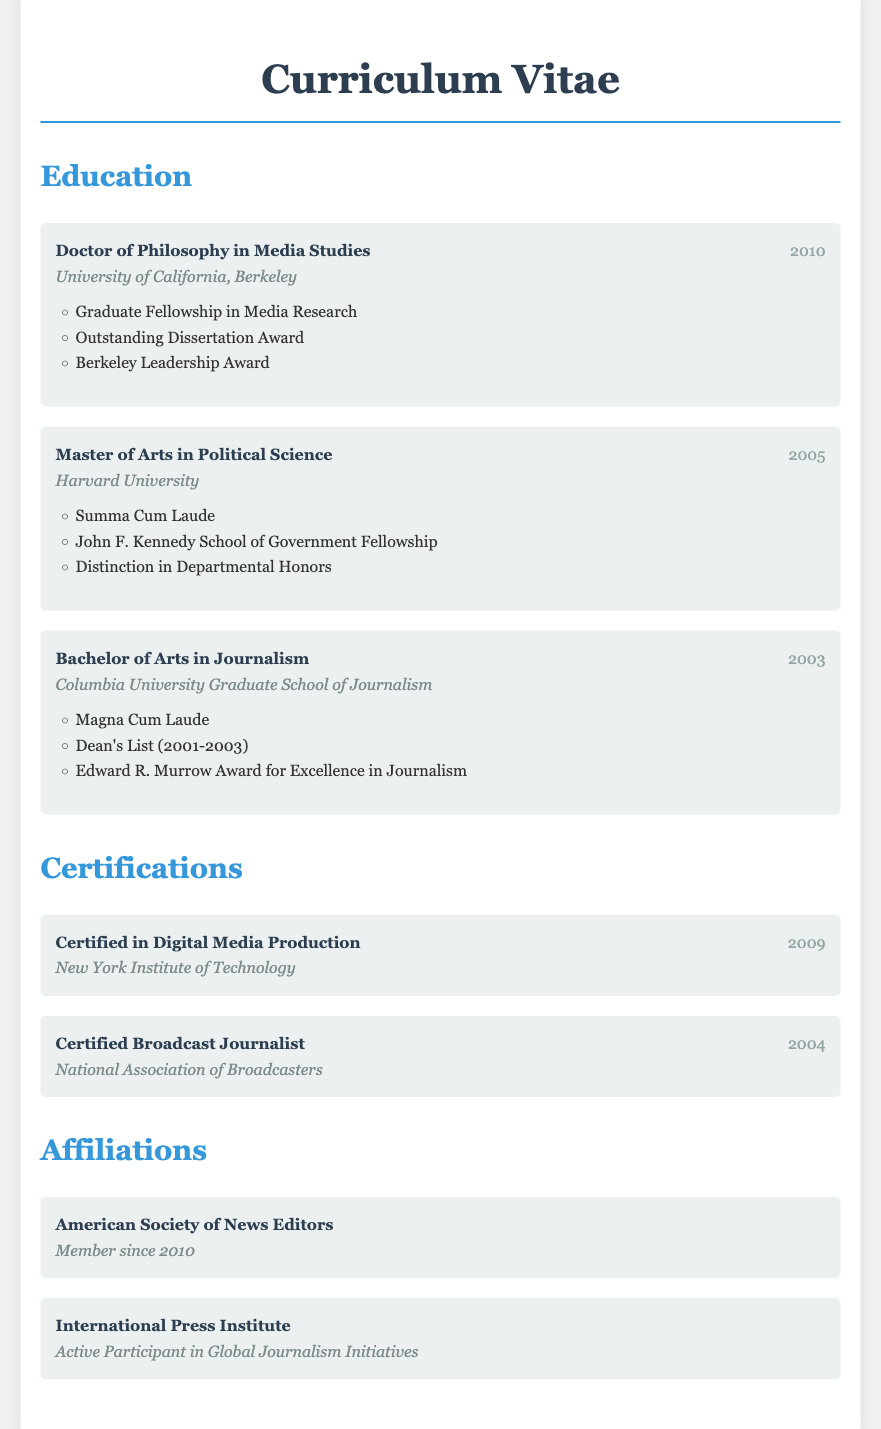What degree was earned in 2010? The document specifies that a Doctor of Philosophy in Media Studies was earned in 2010.
Answer: Doctor of Philosophy in Media Studies Which institution awarded the Master of Arts degree? The document states that the Master of Arts in Political Science was awarded by Harvard University.
Answer: Harvard University What honors were received for the Bachelor's degree? The information outlines that Magna Cum Laude, Dean's List (2001-2003), and Edward R. Murrow Award for Excellence in Journalism were honors received for the Bachelor's degree.
Answer: Magna Cum Laude, Dean's List (2001-2003), Edward R. Murrow Award How many years apart were the Bachelor's and Doctoral degrees earned? The Bachelor's degree was earned in 2003 and the Doctoral degree in 2010, making them 7 years apart.
Answer: 7 years What certification was earned in 2009? The document lists a certification in Digital Media Production earned in 2009.
Answer: Certified in Digital Media Production Which organization has the individual been a member of since 2010? The document indicates that the individual has been a member of the American Society of News Editors since 2010.
Answer: American Society of News Editors What prestigious fellowship was awarded at Harvard University? The document mentions that the John F. Kennedy School of Government Fellowship was awarded during the Master's program at Harvard University.
Answer: John F. Kennedy School of Government Fellowship How many honors were listed under the Doctor of Philosophy degree? Three honors are mentioned for the Doctor of Philosophy in Media Studies degree: Graduate Fellowship in Media Research, Outstanding Dissertation Award, and Berkeley Leadership Award.
Answer: 3 honors 